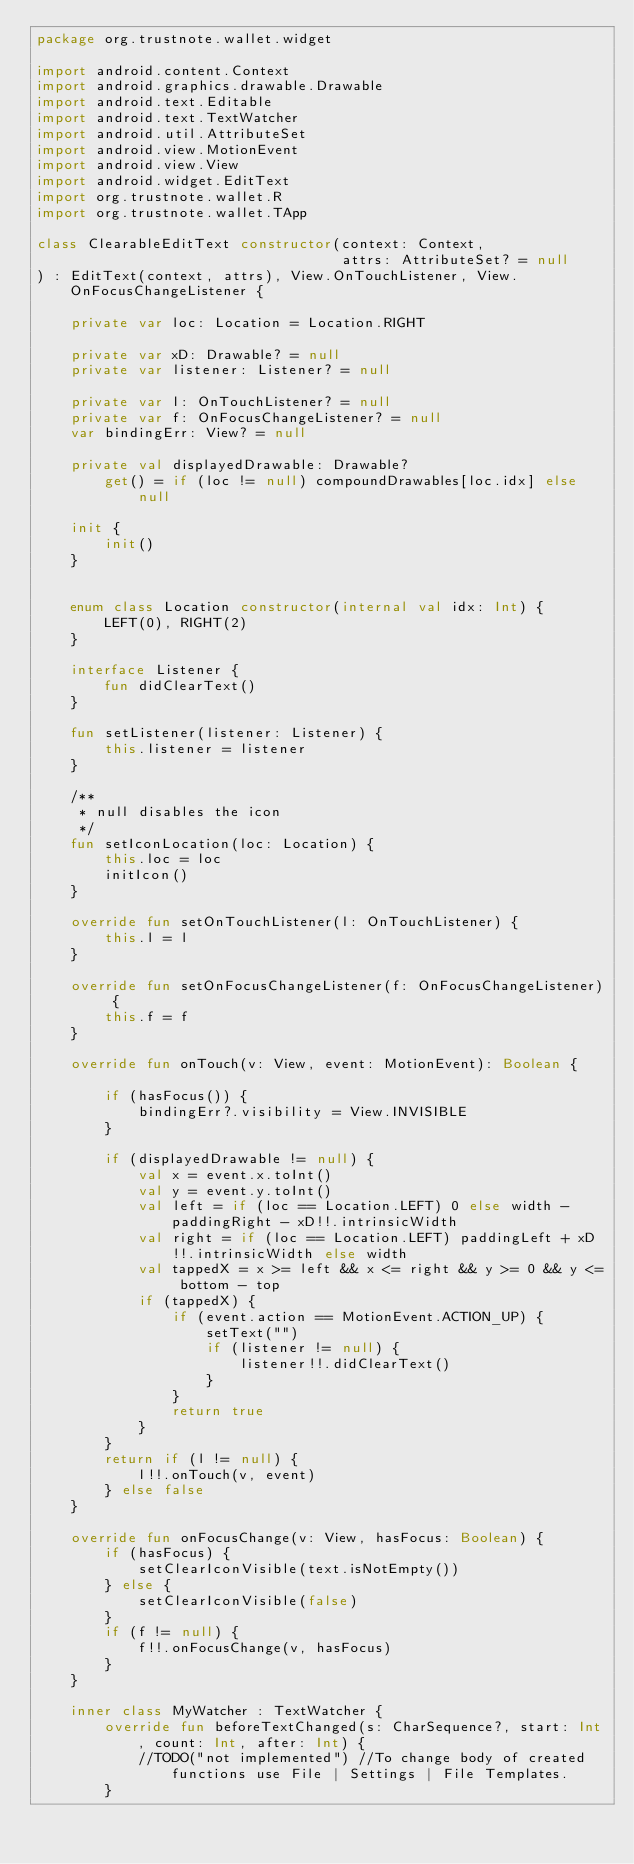Convert code to text. <code><loc_0><loc_0><loc_500><loc_500><_Kotlin_>package org.trustnote.wallet.widget

import android.content.Context
import android.graphics.drawable.Drawable
import android.text.Editable
import android.text.TextWatcher
import android.util.AttributeSet
import android.view.MotionEvent
import android.view.View
import android.widget.EditText
import org.trustnote.wallet.R
import org.trustnote.wallet.TApp

class ClearableEditText constructor(context: Context,
                                    attrs: AttributeSet? = null
) : EditText(context, attrs), View.OnTouchListener, View.OnFocusChangeListener {

    private var loc: Location = Location.RIGHT

    private var xD: Drawable? = null
    private var listener: Listener? = null

    private var l: OnTouchListener? = null
    private var f: OnFocusChangeListener? = null
    var bindingErr: View? = null

    private val displayedDrawable: Drawable?
        get() = if (loc != null) compoundDrawables[loc.idx] else null

    init {
        init()
    }


    enum class Location constructor(internal val idx: Int) {
        LEFT(0), RIGHT(2)
    }

    interface Listener {
        fun didClearText()
    }

    fun setListener(listener: Listener) {
        this.listener = listener
    }

    /**
     * null disables the icon
     */
    fun setIconLocation(loc: Location) {
        this.loc = loc
        initIcon()
    }

    override fun setOnTouchListener(l: OnTouchListener) {
        this.l = l
    }

    override fun setOnFocusChangeListener(f: OnFocusChangeListener) {
        this.f = f
    }

    override fun onTouch(v: View, event: MotionEvent): Boolean {

        if (hasFocus()) {
            bindingErr?.visibility = View.INVISIBLE
        }

        if (displayedDrawable != null) {
            val x = event.x.toInt()
            val y = event.y.toInt()
            val left = if (loc == Location.LEFT) 0 else width - paddingRight - xD!!.intrinsicWidth
            val right = if (loc == Location.LEFT) paddingLeft + xD!!.intrinsicWidth else width
            val tappedX = x >= left && x <= right && y >= 0 && y <= bottom - top
            if (tappedX) {
                if (event.action == MotionEvent.ACTION_UP) {
                    setText("")
                    if (listener != null) {
                        listener!!.didClearText()
                    }
                }
                return true
            }
        }
        return if (l != null) {
            l!!.onTouch(v, event)
        } else false
    }

    override fun onFocusChange(v: View, hasFocus: Boolean) {
        if (hasFocus) {
            setClearIconVisible(text.isNotEmpty())
        } else {
            setClearIconVisible(false)
        }
        if (f != null) {
            f!!.onFocusChange(v, hasFocus)
        }
    }

    inner class MyWatcher : TextWatcher {
        override fun beforeTextChanged(s: CharSequence?, start: Int, count: Int, after: Int) {
            //TODO("not implemented") //To change body of created functions use File | Settings | File Templates.
        }
</code> 